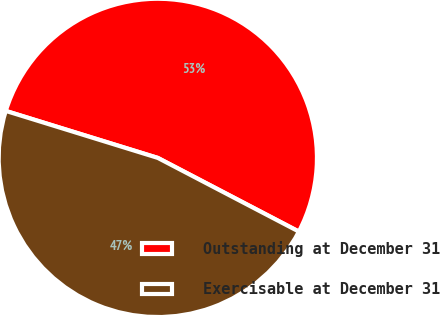Convert chart to OTSL. <chart><loc_0><loc_0><loc_500><loc_500><pie_chart><fcel>Outstanding at December 31<fcel>Exercisable at December 31<nl><fcel>52.89%<fcel>47.11%<nl></chart> 